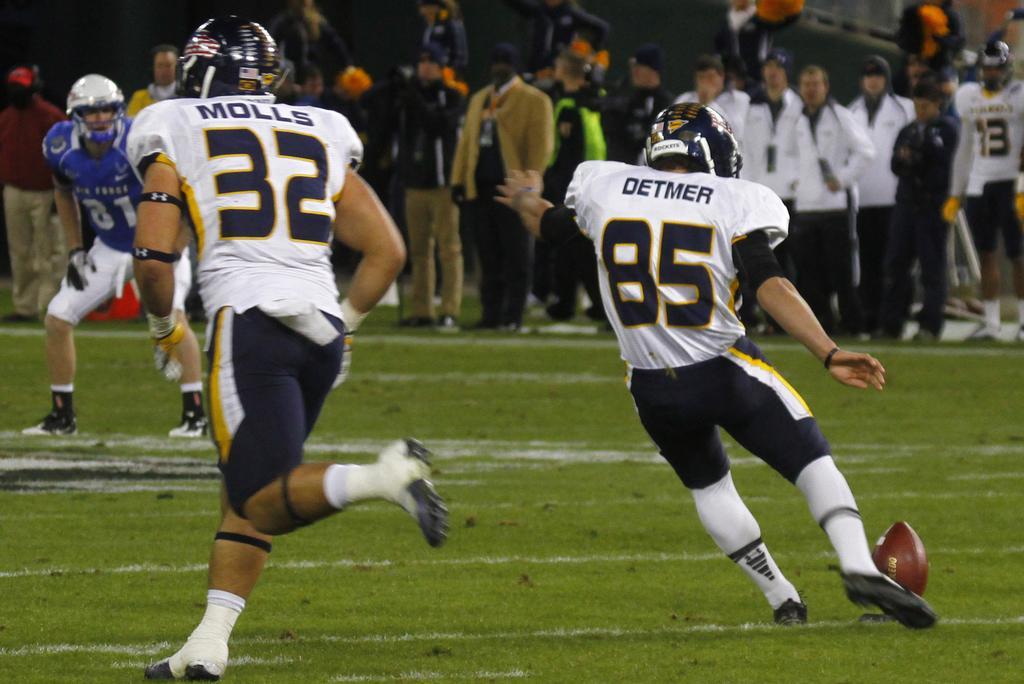How would you summarize this image in a sentence or two? There is a group of a people. There is a ground. On the left side of the person is running. He's wearing a helmet. On the right side of the person is wearing helmet. His hitting ball with leg. Both are wearing a colorful white shirts. 